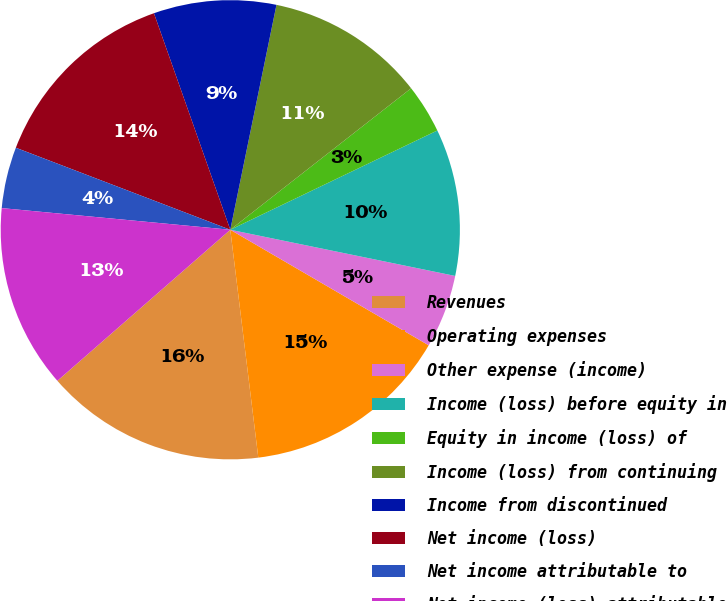<chart> <loc_0><loc_0><loc_500><loc_500><pie_chart><fcel>Revenues<fcel>Operating expenses<fcel>Other expense (income)<fcel>Income (loss) before equity in<fcel>Equity in income (loss) of<fcel>Income (loss) from continuing<fcel>Income from discontinued<fcel>Net income (loss)<fcel>Net income attributable to<fcel>Net income (loss) attributable<nl><fcel>15.52%<fcel>14.66%<fcel>5.17%<fcel>10.34%<fcel>3.45%<fcel>11.21%<fcel>8.62%<fcel>13.79%<fcel>4.31%<fcel>12.93%<nl></chart> 